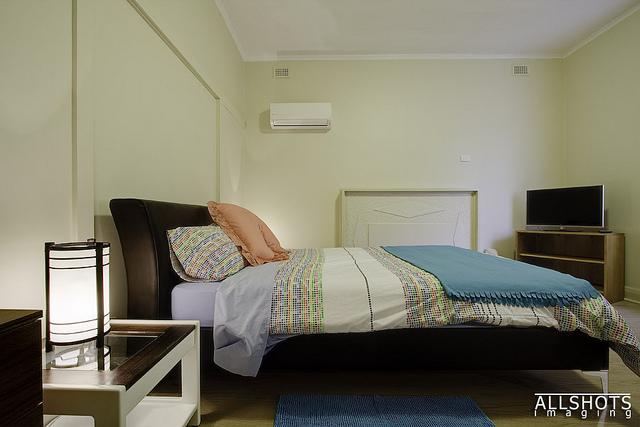Is the lamp on?
Be succinct. Yes. What color is the blanket?
Write a very short answer. Blue. Is this a typical shaped bed?
Quick response, please. Yes. How many items are on the bookshelf in the background?
Write a very short answer. 1. What material is the top of the table made of?
Give a very brief answer. Glass. 